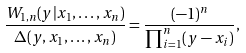<formula> <loc_0><loc_0><loc_500><loc_500>\frac { W _ { 1 , n } ( y | x _ { 1 } , \dots , x _ { n } ) } { \Delta ( y , x _ { 1 } , \dots , x _ { n } ) } = \frac { ( - 1 ) ^ { n } } { \prod ^ { n } _ { i = 1 } ( y - x _ { i } ) } ,</formula> 